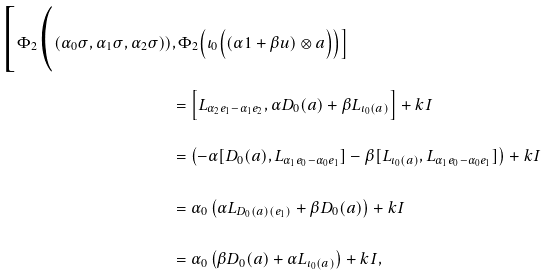<formula> <loc_0><loc_0><loc_500><loc_500>\Big [ \Phi _ { 2 } \Big ( ( \alpha _ { 0 } \sigma , \alpha _ { 1 } \sigma , \alpha _ { 2 } \sigma ) ) & , \Phi _ { 2 } \Big ( \iota _ { 0 } \Big ( ( \alpha 1 + \beta u ) \otimes a \Big ) \Big ) \Big ] \\ & = \Big [ L _ { \alpha _ { 2 } e _ { 1 } - \alpha _ { 1 } e _ { 2 } } , \alpha D _ { 0 } ( a ) + \beta L _ { \iota _ { 0 } ( a ) } \Big ] + k I \\ & = \left ( - \alpha [ D _ { 0 } ( a ) , L _ { \alpha _ { 1 } e _ { 0 } - \alpha _ { 0 } e _ { 1 } } ] - \beta [ L _ { \iota _ { 0 } ( a ) } , L _ { \alpha _ { 1 } e _ { 0 } - \alpha _ { 0 } e _ { 1 } } ] \right ) + k I \\ & = \alpha _ { 0 } \left ( \alpha L _ { D _ { 0 } ( a ) ( e _ { 1 } ) } + \beta D _ { 0 } ( a ) \right ) + k I \\ & = \alpha _ { 0 } \left ( \beta D _ { 0 } ( a ) + \alpha L _ { \iota _ { 0 } ( a ) } \right ) + k I ,</formula> 